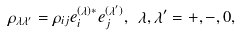Convert formula to latex. <formula><loc_0><loc_0><loc_500><loc_500>\rho _ { \lambda \lambda ^ { \prime } } = \rho _ { i j } e _ { i } ^ { ( \lambda ) * } e _ { j } ^ { ( \lambda ^ { \prime } ) } , \ \lambda , \lambda ^ { \prime } = + , - , 0 ,</formula> 